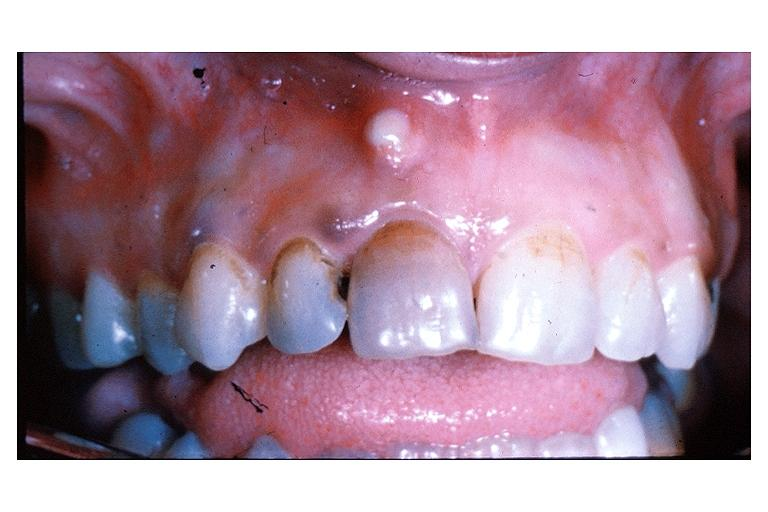s oral present?
Answer the question using a single word or phrase. Yes 